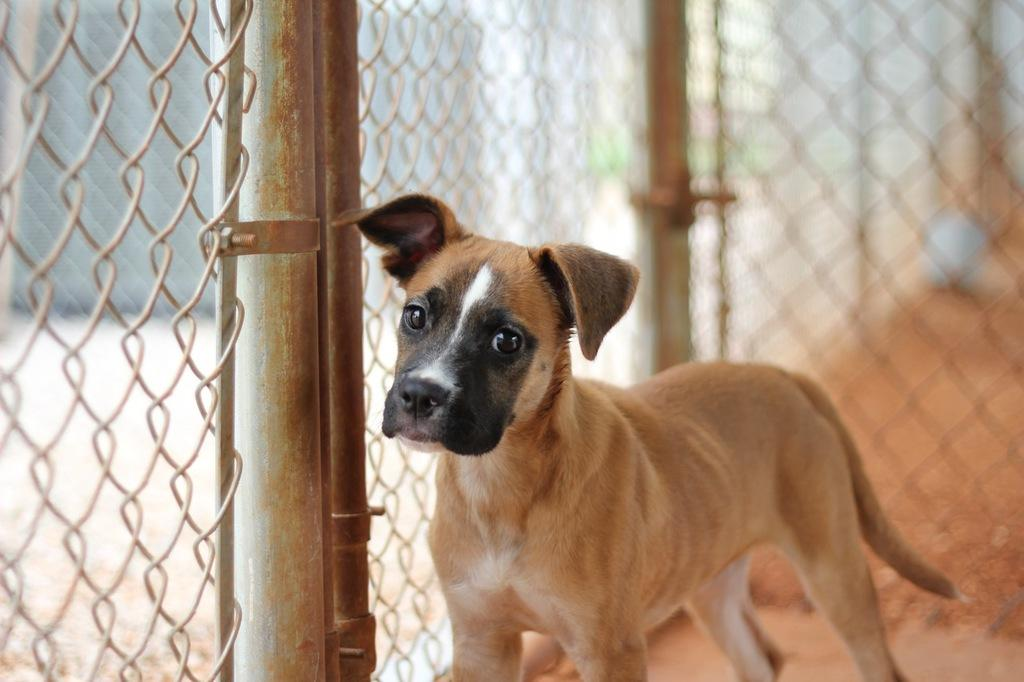What animal can be seen in the image? There is a dog in the image. Where is the dog positioned in relation to the fence? The dog is standing beside a fence. What can be seen on the left side of the image? There is a grill on the left side of the image. What is located beside the grill? There is a pole beside the grill. What type of stone is being used to make pancakes in the image? There is no stone or pancakes present in the image. What shape is the circle in the image? There is no circle present in the image. 